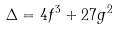<formula> <loc_0><loc_0><loc_500><loc_500>\Delta = 4 f ^ { 3 } + 2 7 g ^ { 2 }</formula> 